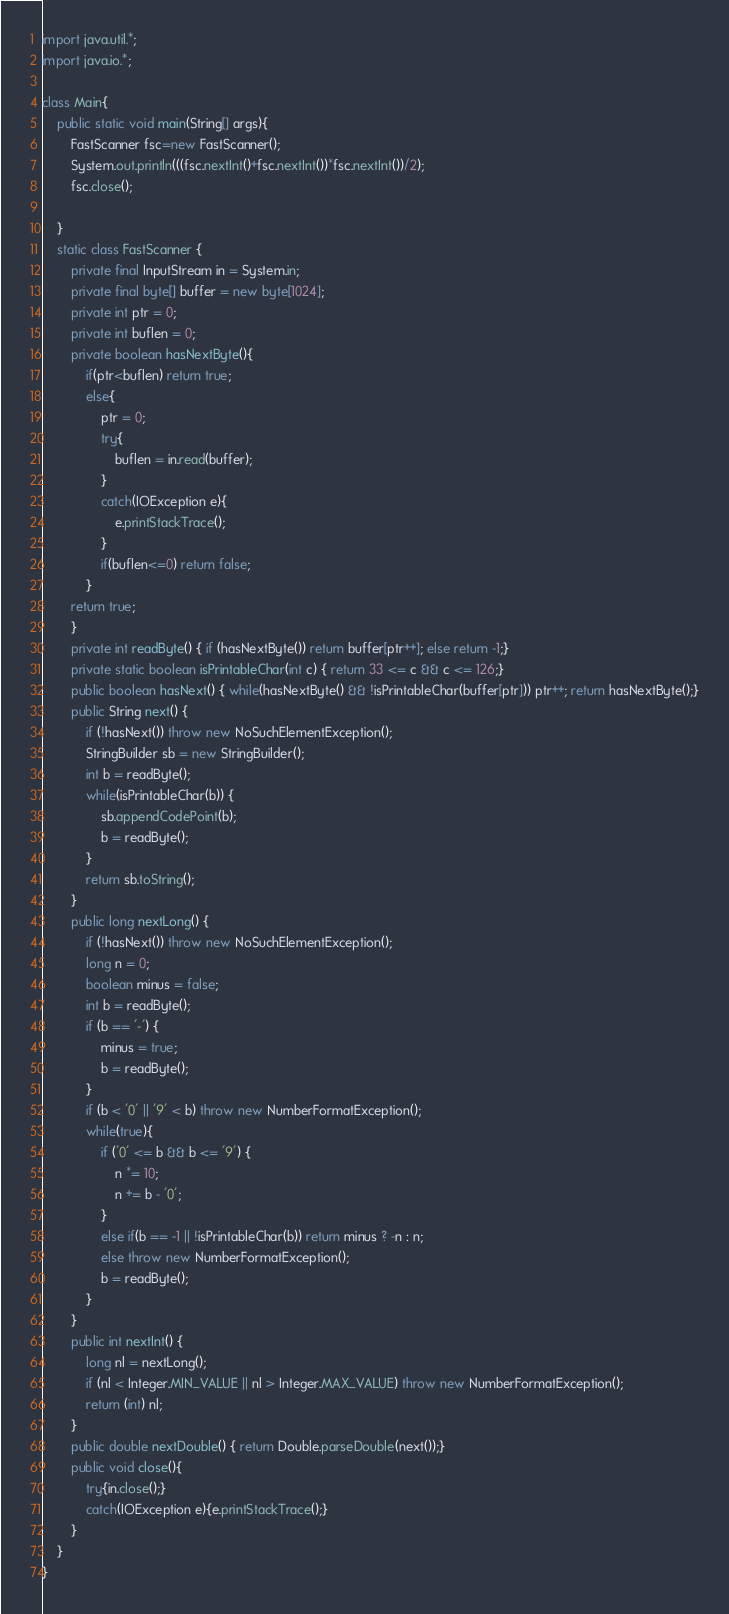<code> <loc_0><loc_0><loc_500><loc_500><_Java_>import java.util.*;
import java.io.*;

class Main{
    public static void main(String[] args){
        FastScanner fsc=new FastScanner();
        System.out.println(((fsc.nextInt()+fsc.nextInt())*fsc.nextInt())/2);
        fsc.close();
        
    }
    static class FastScanner {
        private final InputStream in = System.in;
        private final byte[] buffer = new byte[1024];
        private int ptr = 0;
        private int buflen = 0;
        private boolean hasNextByte(){
            if(ptr<buflen) return true;
            else{
                ptr = 0;
                try{
                    buflen = in.read(buffer);
                }
                catch(IOException e){
                    e.printStackTrace();
                }
                if(buflen<=0) return false;
            }
        return true;
        }
        private int readByte() { if (hasNextByte()) return buffer[ptr++]; else return -1;}
        private static boolean isPrintableChar(int c) { return 33 <= c && c <= 126;}
        public boolean hasNext() { while(hasNextByte() && !isPrintableChar(buffer[ptr])) ptr++; return hasNextByte();}
        public String next() {
            if (!hasNext()) throw new NoSuchElementException();
            StringBuilder sb = new StringBuilder();
            int b = readByte();
            while(isPrintableChar(b)) {
                sb.appendCodePoint(b);
                b = readByte();
            }
            return sb.toString();
        }
        public long nextLong() {
            if (!hasNext()) throw new NoSuchElementException();
            long n = 0;
            boolean minus = false;
            int b = readByte();
            if (b == '-') {
                minus = true;
                b = readByte();
            }
            if (b < '0' || '9' < b) throw new NumberFormatException();
            while(true){
                if ('0' <= b && b <= '9') {
                    n *= 10;
                    n += b - '0';
                }
                else if(b == -1 || !isPrintableChar(b)) return minus ? -n : n;
                else throw new NumberFormatException();
                b = readByte();
            }
        }
        public int nextInt() {
            long nl = nextLong();
            if (nl < Integer.MIN_VALUE || nl > Integer.MAX_VALUE) throw new NumberFormatException();
            return (int) nl;
        }
        public double nextDouble() { return Double.parseDouble(next());}
        public void close(){
            try{in.close();}
            catch(IOException e){e.printStackTrace();}
        }
    }
}
</code> 